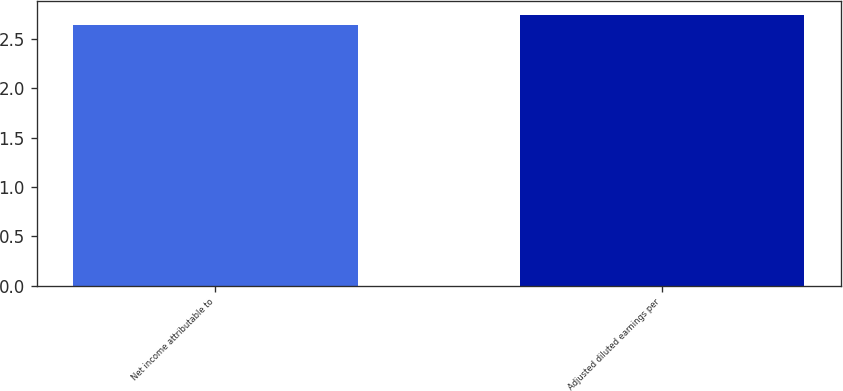Convert chart. <chart><loc_0><loc_0><loc_500><loc_500><bar_chart><fcel>Net income attributable to<fcel>Adjusted diluted earnings per<nl><fcel>2.64<fcel>2.74<nl></chart> 